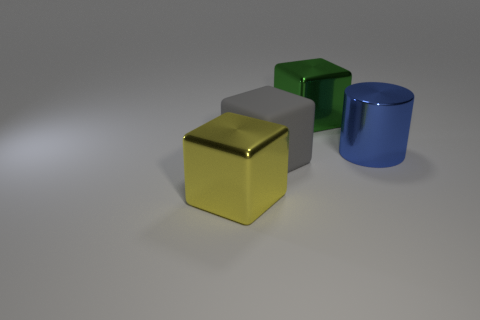Is there any other thing of the same color as the matte cube?
Provide a short and direct response. No. What is the shape of the green thing that is the same material as the large yellow thing?
Make the answer very short. Cube. What is the object that is behind the large gray rubber thing and on the left side of the big cylinder made of?
Offer a terse response. Metal. Is there anything else that is the same size as the blue metal cylinder?
Provide a short and direct response. Yes. Does the large shiny cylinder have the same color as the matte cube?
Ensure brevity in your answer.  No. How many purple rubber objects have the same shape as the large green object?
Offer a very short reply. 0. There is a yellow object that is the same material as the blue thing; what is its size?
Offer a terse response. Large. Do the blue metal object and the gray matte block have the same size?
Offer a terse response. Yes. Is there a metal object?
Offer a terse response. Yes. How big is the metal thing on the right side of the metal cube behind the large yellow shiny object in front of the big blue shiny thing?
Keep it short and to the point. Large. 